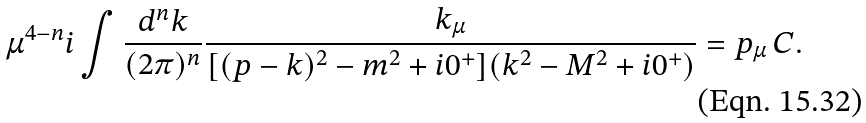Convert formula to latex. <formula><loc_0><loc_0><loc_500><loc_500>\mu ^ { 4 - n } i \int \frac { d ^ { n } k } { ( 2 \pi ) ^ { n } } \frac { k _ { \mu } } { [ ( p - k ) ^ { 2 } - m ^ { 2 } + i 0 ^ { + } ] ( k ^ { 2 } - M ^ { 2 } + i 0 ^ { + } ) } = p _ { \mu } \, C .</formula> 